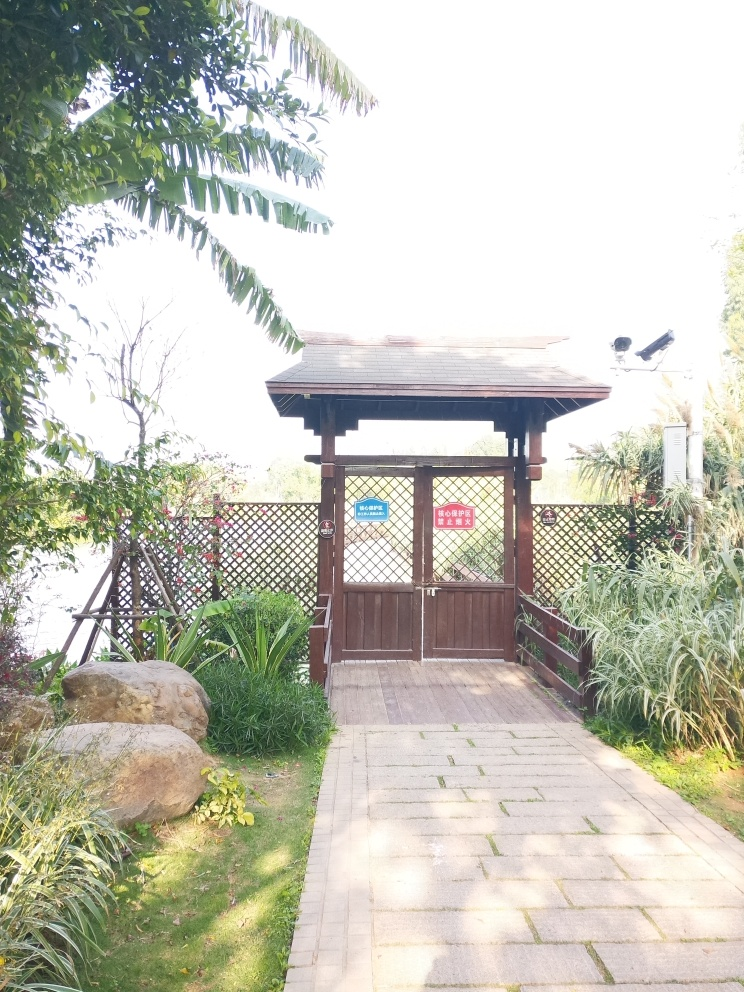What suggestions do you have for improving the composition of this photograph? To improve the composition, the photographer could reduce overexposure in the sky by adjusting the camera settings or choosing a different angle that includes more of the garden and less of the bright sky. Additionally, framing the shot to capture more elements of interest, such as the pathway leading up to the pavilion or the surrounding plants, would enhance the depth and balance of the image. Using the rule of thirds could further strengthen the composition by positioning key elements off-center. 